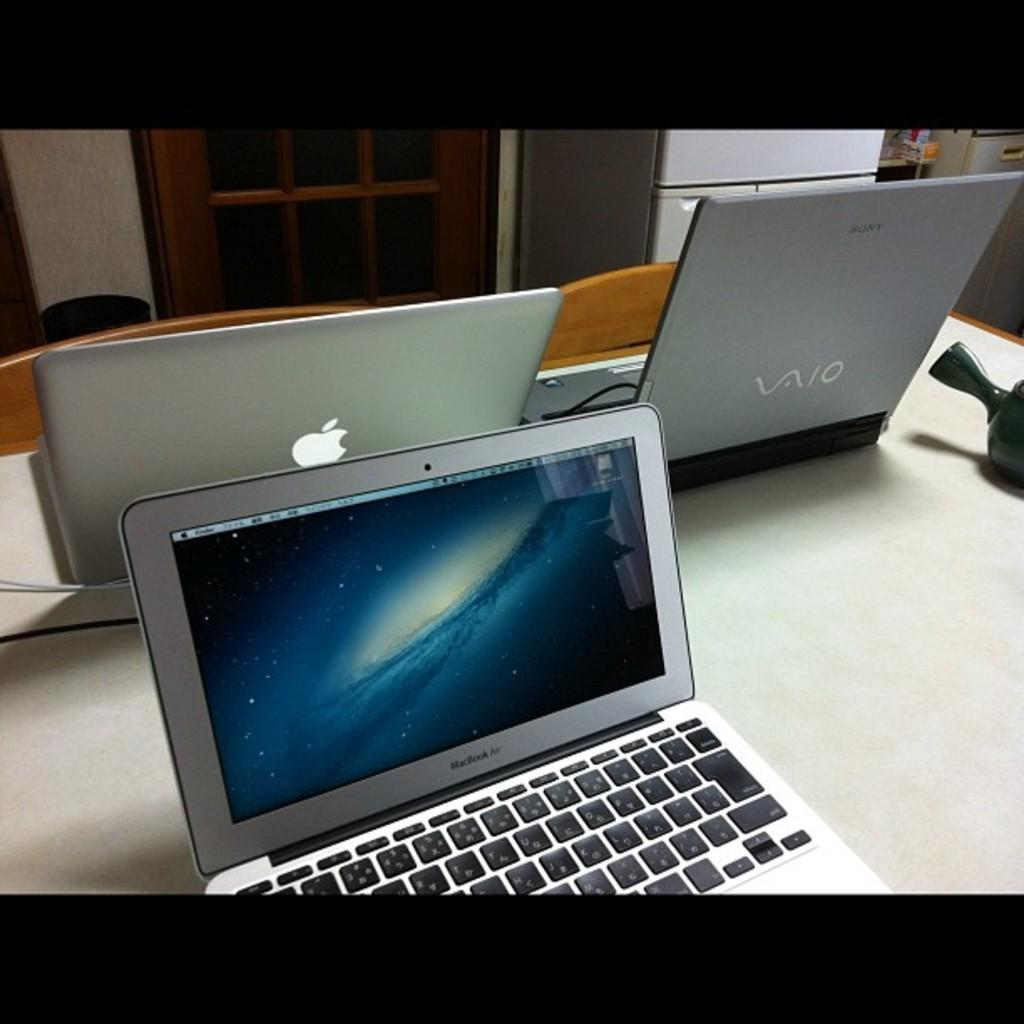<image>
Summarize the visual content of the image. Two macbook airs with a vaio laptop on a table together 